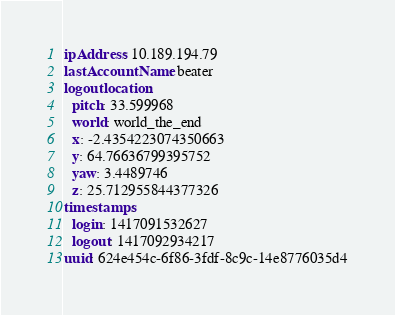Convert code to text. <code><loc_0><loc_0><loc_500><loc_500><_YAML_>ipAddress: 10.189.194.79
lastAccountName: beater
logoutlocation:
  pitch: 33.599968
  world: world_the_end
  x: -2.4354223074350663
  y: 64.76636799395752
  yaw: 3.4489746
  z: 25.712955844377326
timestamps:
  login: 1417091532627
  logout: 1417092934217
uuid: 624e454c-6f86-3fdf-8c9c-14e8776035d4
</code> 